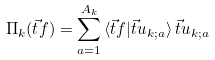Convert formula to latex. <formula><loc_0><loc_0><loc_500><loc_500>\Pi _ { k } ( \vec { t } { f } ) = \sum _ { a = 1 } ^ { A _ { k } } \, \langle \vec { t } { f } | \vec { t } { u } _ { k ; a } \rangle \, \vec { t } { u } _ { k ; a }</formula> 